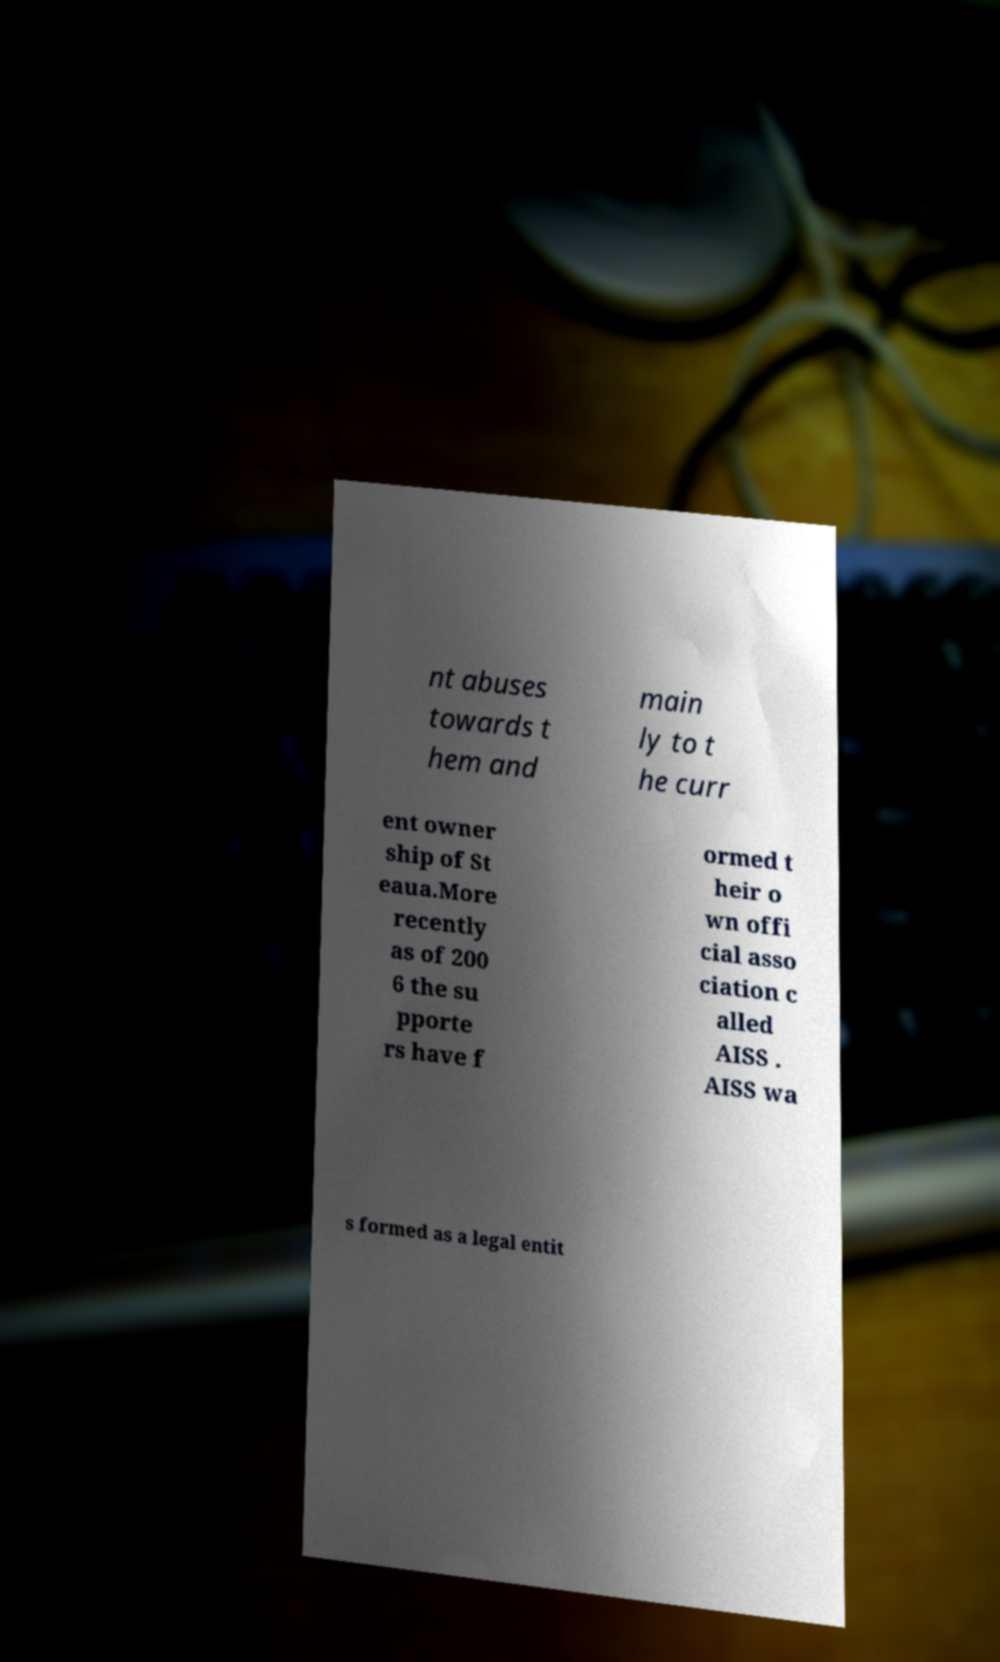I need the written content from this picture converted into text. Can you do that? nt abuses towards t hem and main ly to t he curr ent owner ship of St eaua.More recently as of 200 6 the su pporte rs have f ormed t heir o wn offi cial asso ciation c alled AISS . AISS wa s formed as a legal entit 